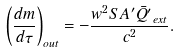Convert formula to latex. <formula><loc_0><loc_0><loc_500><loc_500>\left ( \frac { d m } { d \tau } \right ) _ { o u t } = - \frac { w ^ { 2 } S A ^ { \prime } \bar { Q ^ { \prime } } _ { e x t } } { c ^ { 2 } } .</formula> 